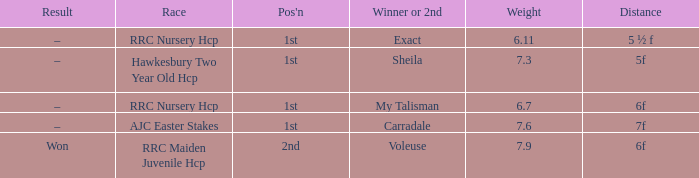What is the largest weight wth a Result of –, and a Distance of 7f? 7.6. 